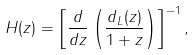<formula> <loc_0><loc_0><loc_500><loc_500>H ( z ) = \left [ \frac { d } { d z } \left ( \frac { d _ { L } ( z ) } { 1 + z } \right ) \right ] ^ { - 1 } ,</formula> 